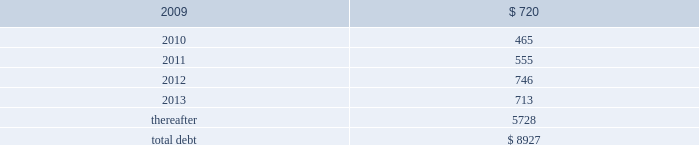Debt maturities 2013 the table presents aggregate debt maturities as of december 31 , 2008 , excluding market value adjustments .
Millions of dollars .
As of december 31 , 2008 , we have reclassified as long-term debt approximately $ 400 million of debt due within one year that we intend to refinance .
This reclassification reflects our ability and intent to refinance any short-term borrowings and certain current maturities of long-term debt on a long-term basis .
At december 31 , 2007 , we reclassified as long-term debt approximately $ 550 million of debt due within one year that we intended to refinance at that time .
Mortgaged properties 2013 equipment with a carrying value of approximately $ 2.7 billion and $ 2.8 billion at december 31 , 2008 and 2007 , respectively , serves as collateral for capital leases and other types of equipment obligations in accordance with the secured financing arrangements utilized to acquire such railroad equipment .
As a result of the merger of missouri pacific railroad company ( mprr ) with and into uprr on january 1 , 1997 , and pursuant to the underlying indentures for the mprr mortgage bonds , uprr must maintain the same value of assets after the merger in order to comply with the security requirements of the mortgage bonds .
As of the merger date , the value of the mprr assets that secured the mortgage bonds was approximately $ 6.0 billion .
In accordance with the terms of the indentures , this collateral value must be maintained during the entire term of the mortgage bonds irrespective of the outstanding balance of such bonds .
Credit facilities 2013 on december 31 , 2008 , we had $ 1.9 billion of credit available under our revolving credit facility ( the facility ) .
The facility is designated for general corporate purposes and supports the issuance of commercial paper .
We did not draw on the facility during 2008 .
Commitment fees and interest rates payable under the facility are similar to fees and rates available to comparably rated , investment- grade borrowers .
The facility allows borrowings at floating rates based on london interbank offered rates , plus a spread , depending upon our senior unsecured debt ratings .
The facility requires union pacific corporation to maintain a debt-to-net-worth coverage ratio as a condition to making a borrowing .
At december 31 , 2008 , and december 31 , 2007 ( and at all times during these periods ) , we were in compliance with this covenant .
The definition of debt used for purposes of calculating the debt-to-net-worth coverage ratio includes , among other things , certain credit arrangements , capital leases , guarantees and unfunded and vested pension benefits under title iv of erisa .
At december 31 , 2008 , the debt-to-net-worth coverage ratio allowed us to carry up to $ 30.9 billion of debt ( as defined in the facility ) , and we had $ 9.9 billion of debt ( as defined in the facility ) outstanding at that date .
Under our current capital plans , we expect to continue to satisfy the debt-to-net-worth coverage ratio ; however , many factors beyond our reasonable control ( including the risk factors in item 1a of this report ) could affect our ability to comply with this provision in the future .
The facility does not include any other financial restrictions , credit rating triggers ( other than rating-dependent pricing ) , or any other provision that could require us to post collateral .
The .
What percentage of total aggregate debt maturities as of december 31 , 2008 are due in 20111? 
Computations: (555 / 8927)
Answer: 0.06217. 